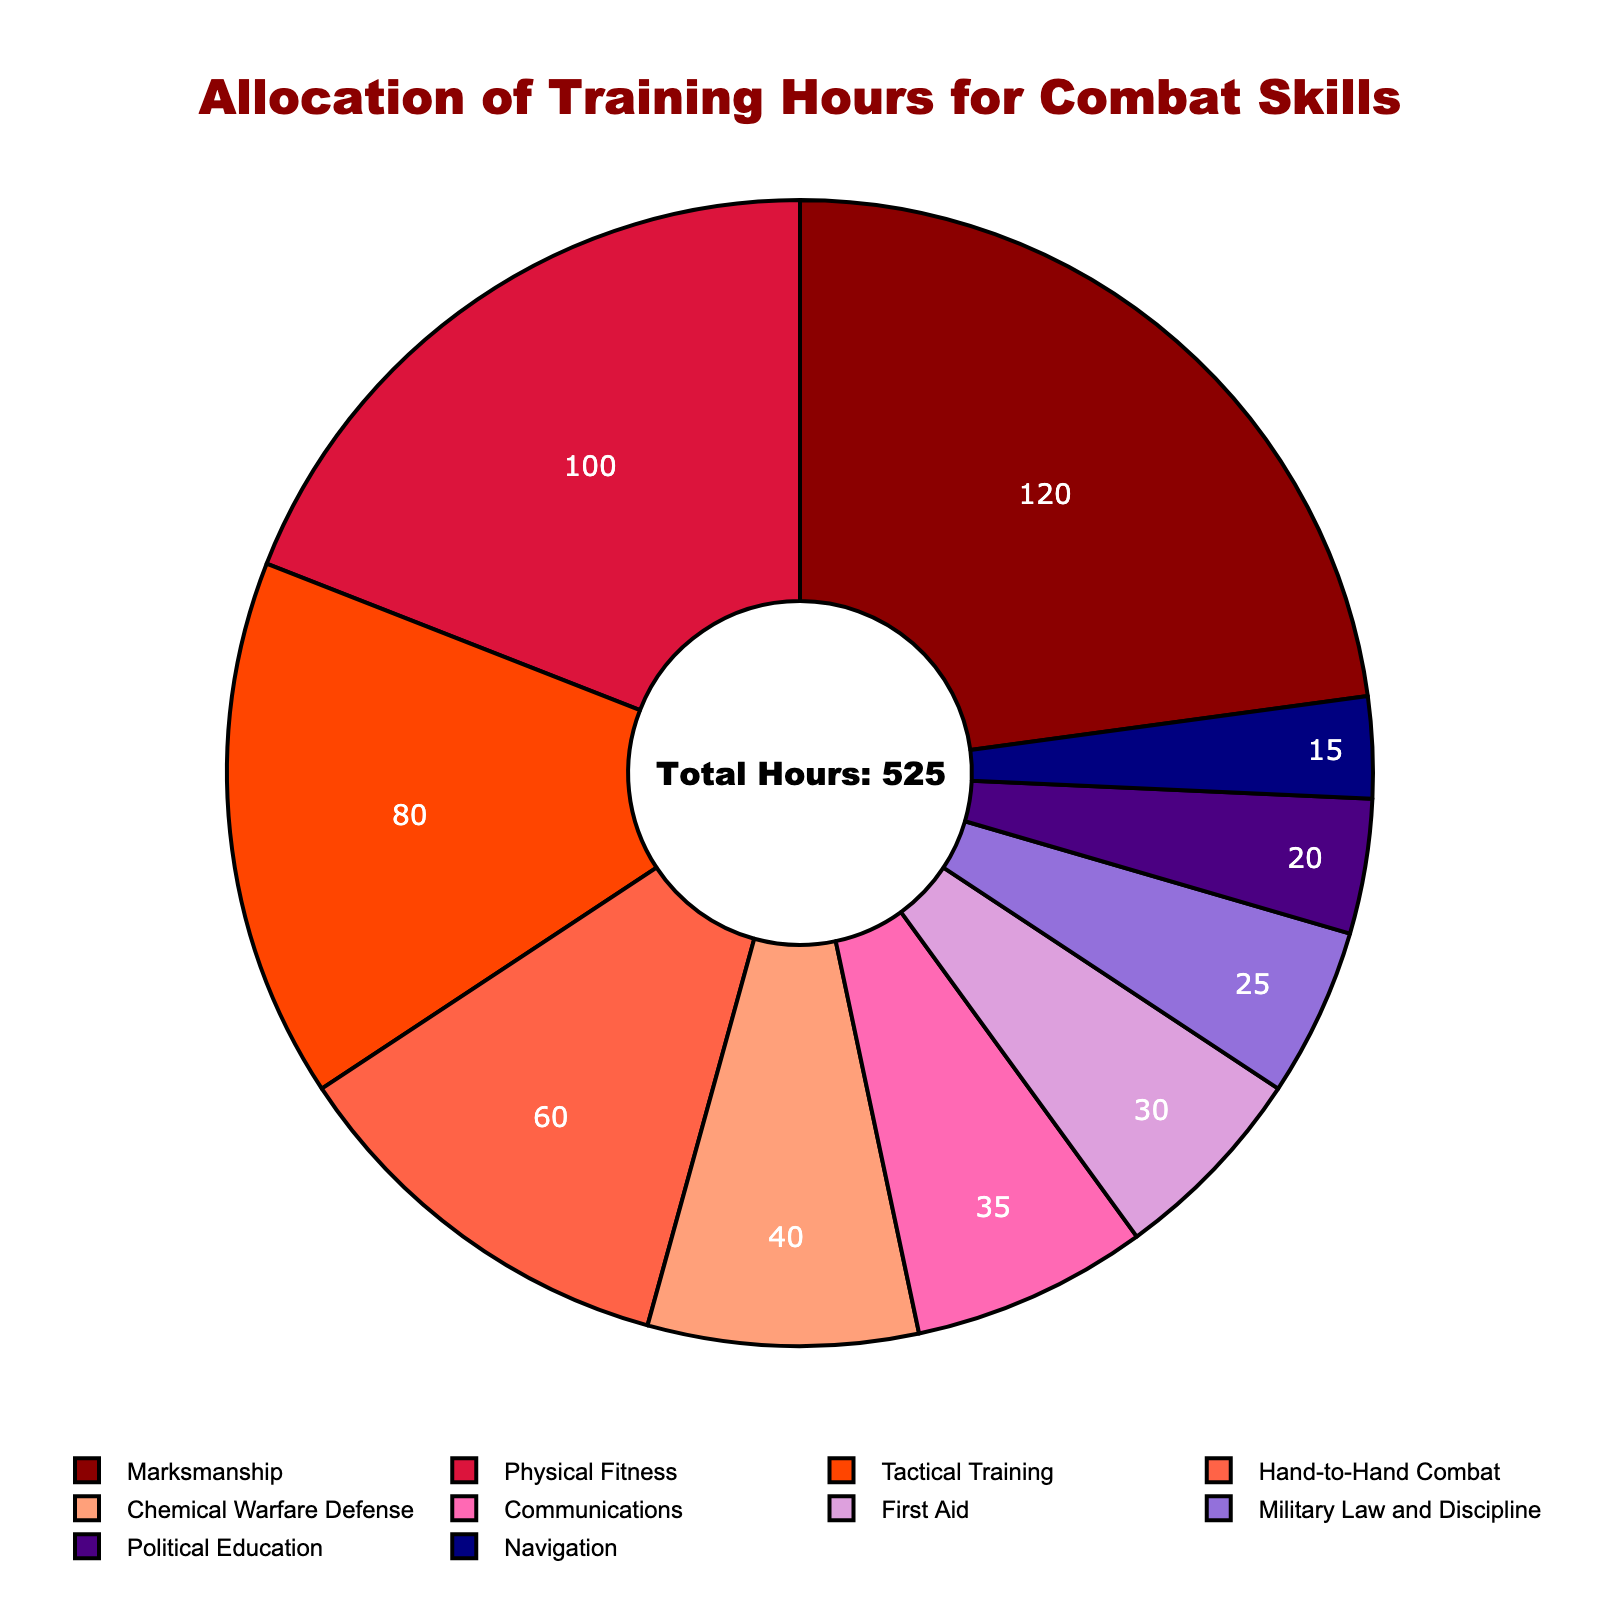What is the skill with the highest allocation of training hours? The skill with the highest allocation of training hours can be identified by looking at the segment with the largest size in the pie chart. The largest segment represents Marksmanship with 120 hours.
Answer: Marksmanship How many more hours are allocated to Marksmanship compared to Hand-to-Hand Combat? First, find the hours allocated to Marksmanship (120) and Hand-to-Hand Combat (60). Then, subtract the hours of Hand-to-Hand Combat from Marksmanship: 120 - 60 = 60.
Answer: 60 Which two skills have the closest allocation of training hours? By looking at the pie chart, Communication (35) and First Aid (30) have the closest allocation of training hours with a difference of only 5 hours.
Answer: Communication and First Aid What percentage of the total training hours is allocated to Physical Fitness? The total hours are shown in the chart as 525. The hours for Physical Fitness are 100. To find the percentage, divide the Physical Fitness hours by the total hours and multiply by 100: (100 / 525) * 100 ≈ 19.05%.
Answer: ≈ 19.05% Is Chemical Warfare Defense allocated more or less training hours than Tactical Training? Compare the size of the segments for Chemical Warfare Defense (40 hours) and Tactical Training (80 hours). Chemical Warfare Defense is allocated fewer hours.
Answer: Less What is the combined percentage of training hours allocated to Tactical Training and Physical Fitness? First, find the hours for Tactical Training (80) and Physical Fitness (100). The combined hours are 80 + 100 = 180. The total hours are 525. Now, calculate the percentage: (180 / 525) * 100 ≈ 34.29%.
Answer: ≈ 34.29% Which skill has the smallest allocation of training hours, and what is its visual color representation in the chart? The smallest allocation is for Navigation with 15 hours. The color representing Navigation can be found visually in the chart; it is represented in navy blue color.
Answer: Navigation, navy blue Is the allocation of hours for Communications more than 5% of the total training hours? Total hours are 525. The hours for Communications are 35. Calculate the percentage: (35 / 525) * 100 ≈ 6.67%. Since 6.67% is greater than 5%, Communications hours are more than 5%.
Answer: Yes By how many hours does the allocation for Political Education and Military Law and Discipline together exceed Navigation? First, find the hours for Political Education (20) and Military Law and Discipline (25). The combined hours are 20 + 25 = 45. Navigation hours are 15. Compare the combined and Navigation hours: 45 - 15 = 30.
Answer: 30 